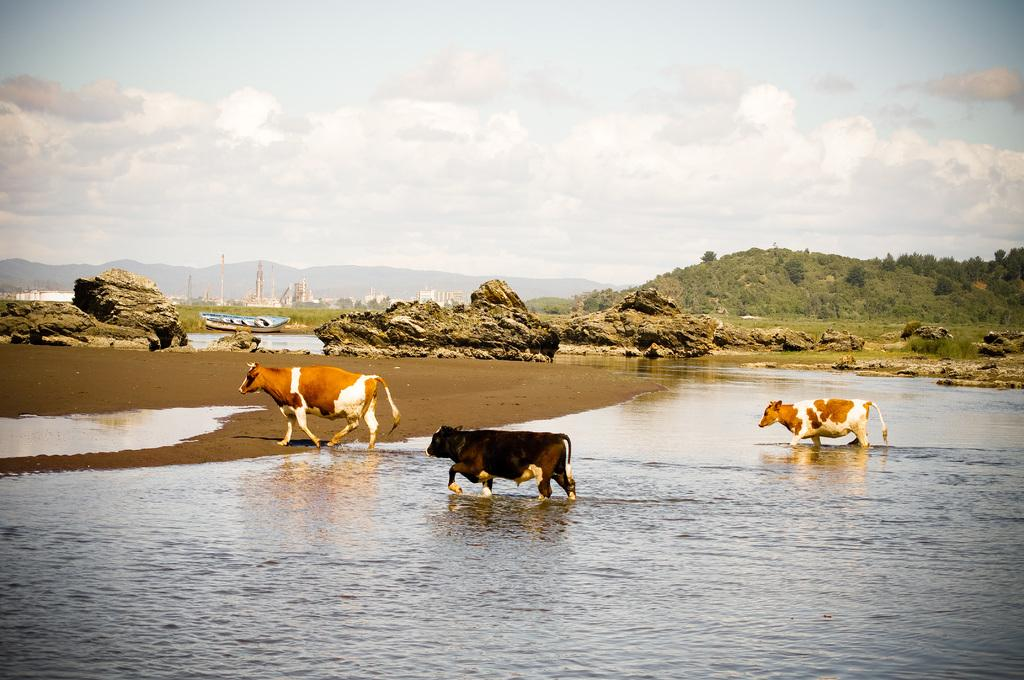How many cows can be seen in the image? There are three cows in the image. What is visible in the image besides the cows? Water, rocks, a boat, trees, buildings, mountains, and some unspecified objects are visible in the image. Can you describe the natural environment in the image? The natural environment includes water, rocks, trees, mountains, and some unspecified objects. What is visible in the sky in the image? The sky is visible in the background of the image, and clouds are present. What type of brush is being used to paint the time on the mountains in the image? There is no brush or painting activity present in the image; the mountains are a natural part of the landscape. 